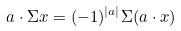Convert formula to latex. <formula><loc_0><loc_0><loc_500><loc_500>a \cdot \Sigma x = ( - 1 ) ^ { | a | } \Sigma ( a \cdot x )</formula> 